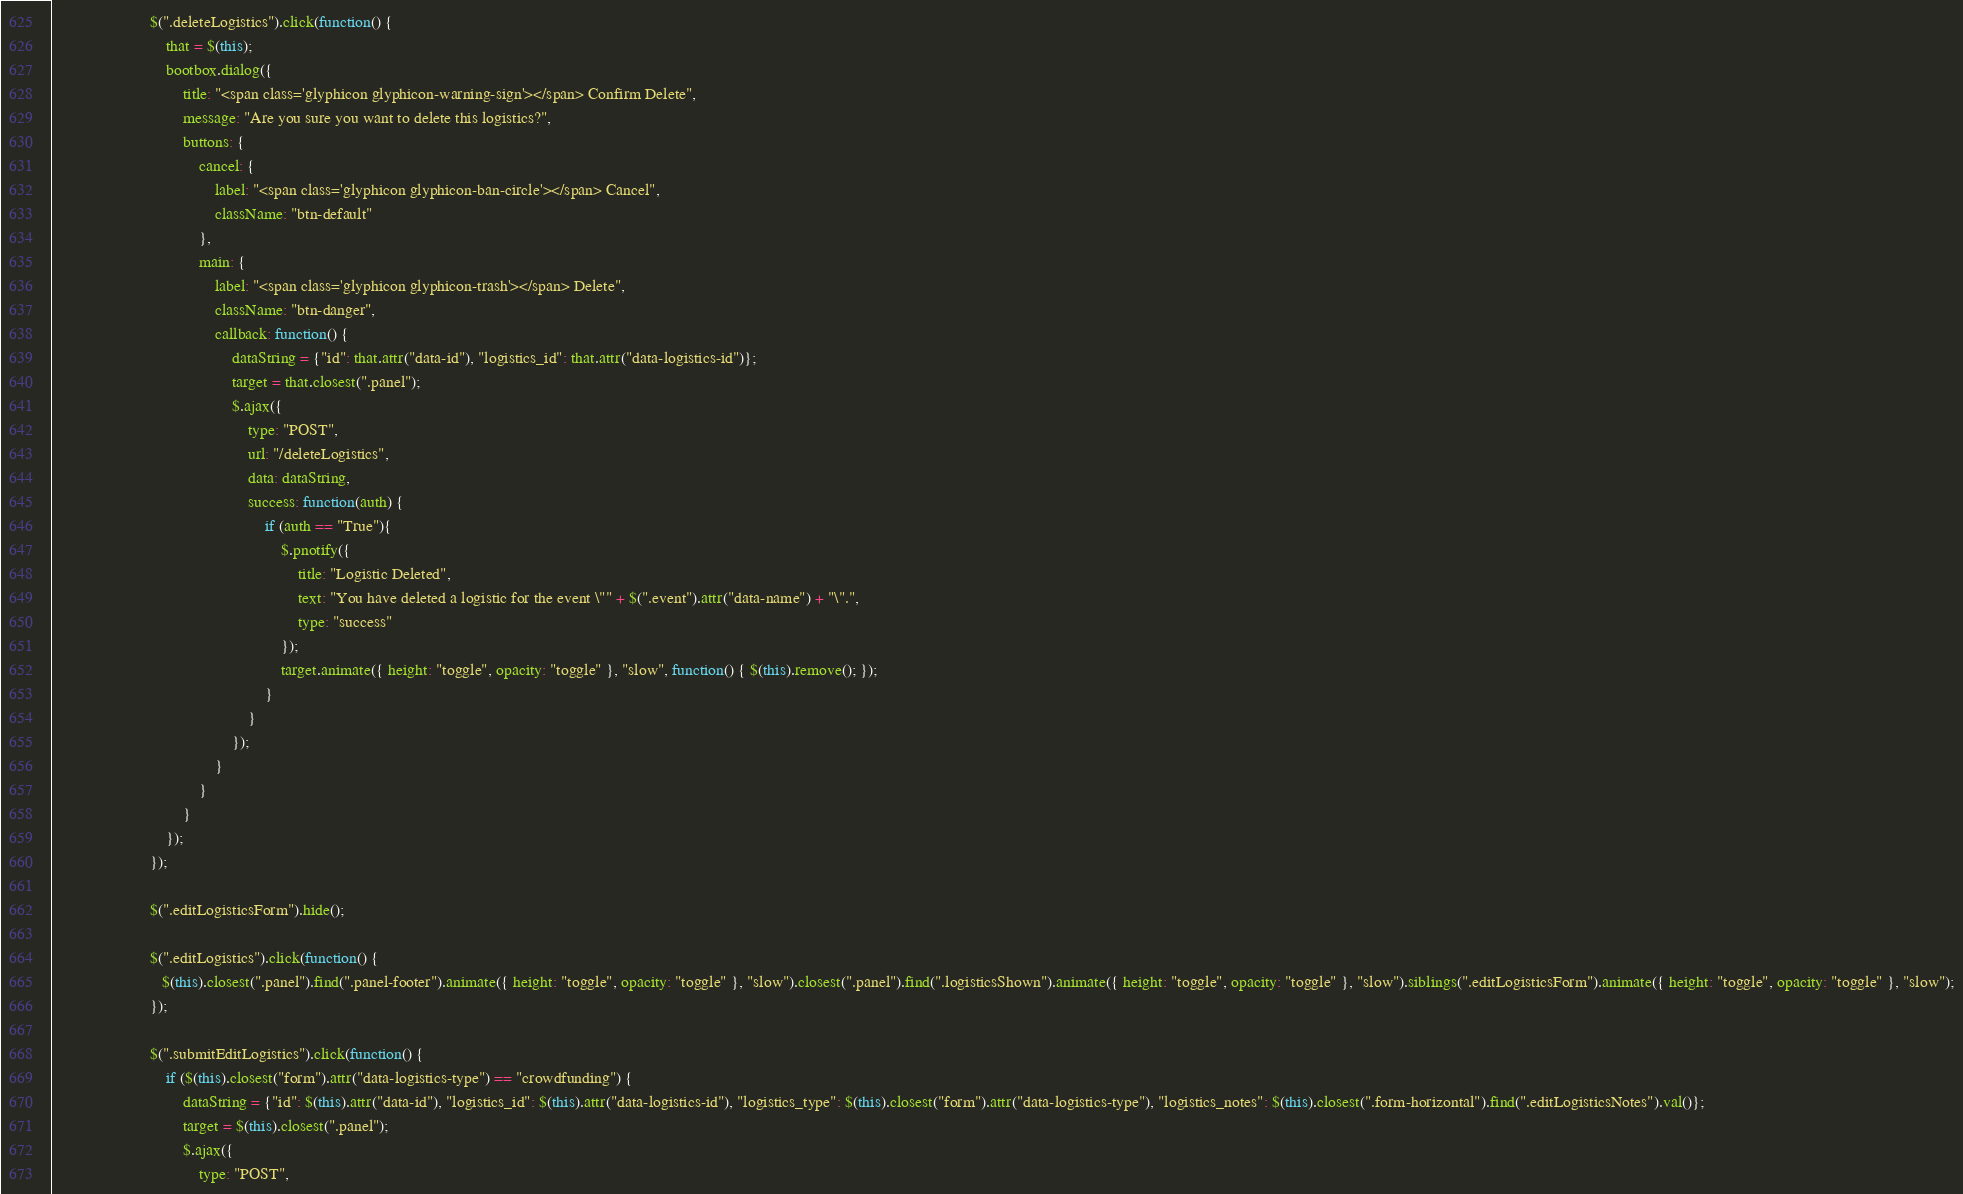<code> <loc_0><loc_0><loc_500><loc_500><_JavaScript_>
                        $(".deleteLogistics").click(function() {
                            that = $(this);
                            bootbox.dialog({
                                title: "<span class='glyphicon glyphicon-warning-sign'></span> Confirm Delete",
                                message: "Are you sure you want to delete this logistics?",
                                buttons: {
                                    cancel: {
                                        label: "<span class='glyphicon glyphicon-ban-circle'></span> Cancel",
                                        className: "btn-default"
                                    },
                                    main: {
                                        label: "<span class='glyphicon glyphicon-trash'></span> Delete",
                                        className: "btn-danger",
                                        callback: function() {
                                            dataString = {"id": that.attr("data-id"), "logistics_id": that.attr("data-logistics-id")};
                                            target = that.closest(".panel");
                                            $.ajax({
                                                type: "POST",
                                                url: "/deleteLogistics",
                                                data: dataString,
                                                success: function(auth) {
                                                    if (auth == "True"){
                                                        $.pnotify({
                                                            title: "Logistic Deleted",
                                                            text: "You have deleted a logistic for the event \"" + $(".event").attr("data-name") + "\".",
                                                            type: "success"
                                                        });
                                                        target.animate({ height: "toggle", opacity: "toggle" }, "slow", function() { $(this).remove(); });
                                                    }
                                                }
                                            });
                                        }
                                    }
                                }
                            });
                        });

                        $(".editLogisticsForm").hide();

                        $(".editLogistics").click(function() {
                           $(this).closest(".panel").find(".panel-footer").animate({ height: "toggle", opacity: "toggle" }, "slow").closest(".panel").find(".logisticsShown").animate({ height: "toggle", opacity: "toggle" }, "slow").siblings(".editLogisticsForm").animate({ height: "toggle", opacity: "toggle" }, "slow");
                        });

                        $(".submitEditLogistics").click(function() {
                            if ($(this).closest("form").attr("data-logistics-type") == "crowdfunding") {
                                dataString = {"id": $(this).attr("data-id"), "logistics_id": $(this).attr("data-logistics-id"), "logistics_type": $(this).closest("form").attr("data-logistics-type"), "logistics_notes": $(this).closest(".form-horizontal").find(".editLogisticsNotes").val()};
                                target = $(this).closest(".panel");
                                $.ajax({
                                    type: "POST",</code> 